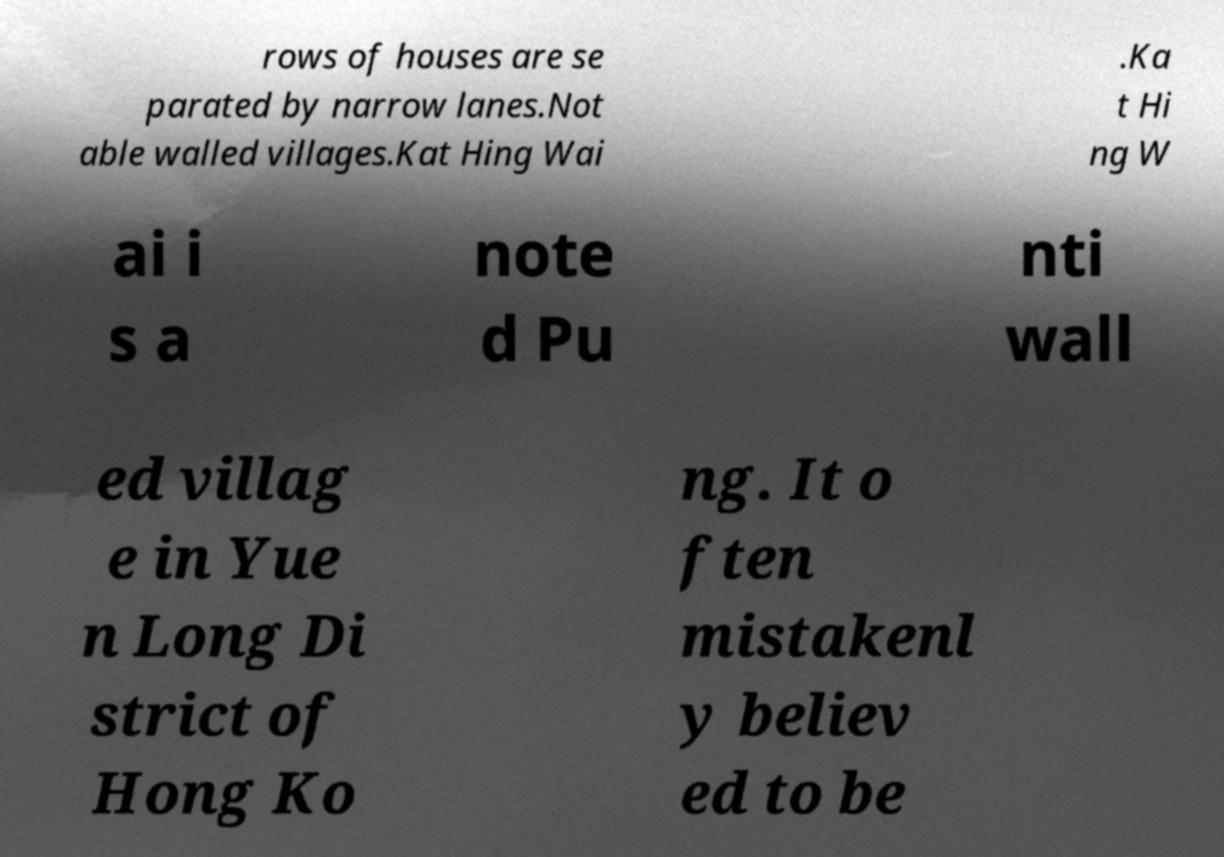What messages or text are displayed in this image? I need them in a readable, typed format. rows of houses are se parated by narrow lanes.Not able walled villages.Kat Hing Wai .Ka t Hi ng W ai i s a note d Pu nti wall ed villag e in Yue n Long Di strict of Hong Ko ng. It o ften mistakenl y believ ed to be 